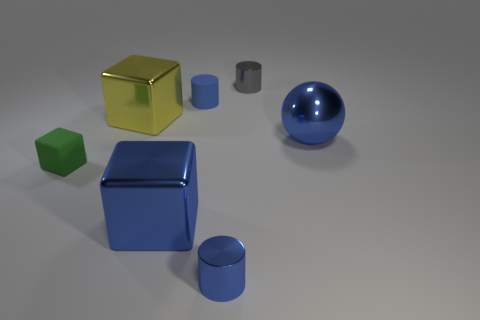Add 1 gray cylinders. How many objects exist? 8 Subtract all cubes. How many objects are left? 4 Add 1 small blue metal objects. How many small blue metal objects exist? 2 Subtract 0 purple cubes. How many objects are left? 7 Subtract all brown cylinders. Subtract all big blue cubes. How many objects are left? 6 Add 6 rubber cylinders. How many rubber cylinders are left? 7 